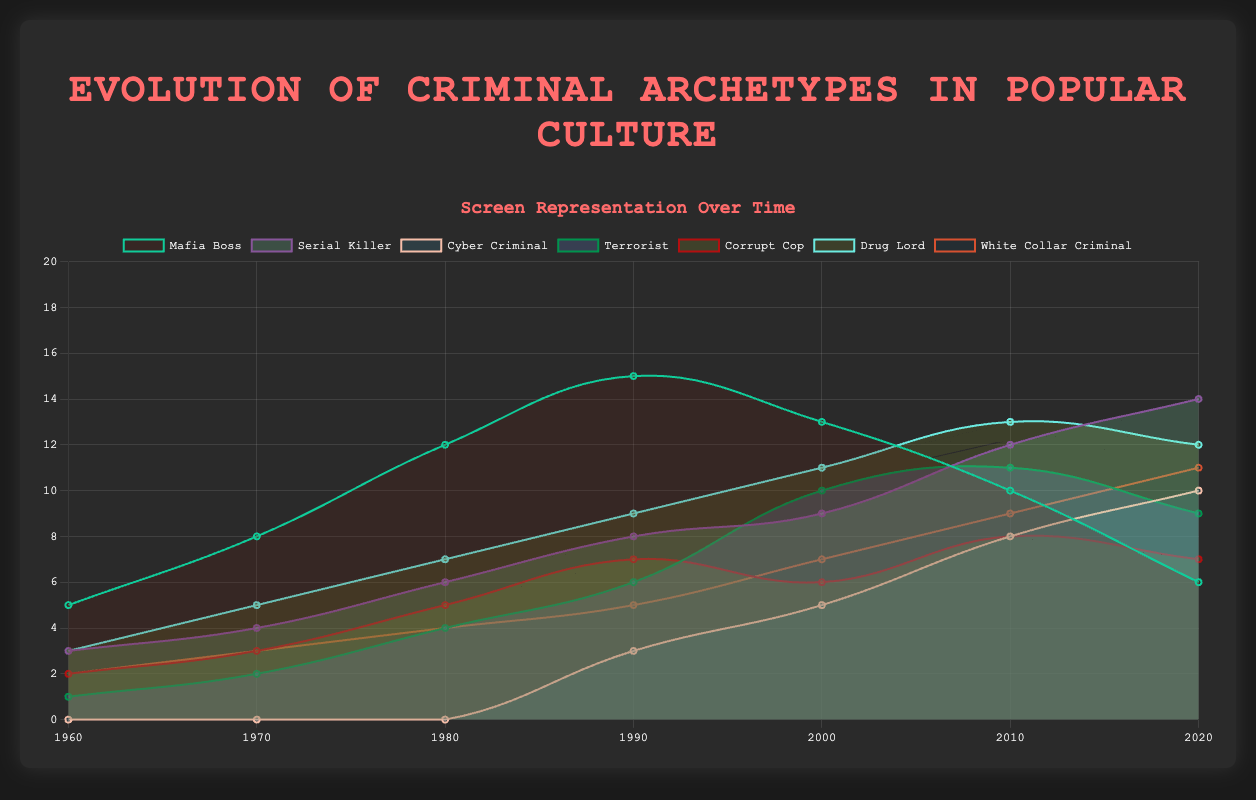What is the title of the chart? The title of the chart is prominently displayed at the top of the figure.
Answer: Evolution of Criminal Archetypes in Popular Culture How many years are represented in the chart? Counting the years provided in the x-axis labels from 1960 to 2020, we see there are 7.
Answer: 7 Which criminal archetype shows the highest screen representation in 2010? Finding the data point in 2010 for each archetype and comparing their values, the highest value is 13 for "Drug Lord".
Answer: Drug Lord By how much did the representation of "Cyber Criminal" increase from 2000 to 2020? "Cyber Criminal" representation in 2000 is 5, and in 2020 it is 10. The increase is calculated as 10 - 5.
Answer: 5 Which archetype had a decline in representation from 2010 to 2020? Observing the trends from 2010 to 2020, "Mafia Boss" (from 10 to 6) and "Terrorist" (from 11 to 9) both show a decline.
Answer: Mafia Boss, Terrorist Which archetype had the lowest representation in 1980? Looking at the values in 1980, "Cyber Criminal" is 0, which is the lowest.
Answer: Cyber Criminal What is the average screen representation of "Serial Killer" throughout the years shown? Summing the values for "Serial Killer" (3, 4, 6, 8, 9, 12, 14) and dividing by 7 (the number of years) gives an average of (3+4+6+8+9+12+14)/7.
Answer: 8 Compare the portrayal trends of "Mafia Boss" and "Serial Killer" over the years. Which had a more consistent increase? Observing both lines, "Serial Killer" shows a steady increase over time, while "Mafia Boss" rises rapidly until 1990 and then decreases.
Answer: Serial Killer Which archetype consistently had a representation higher than 5 from 2000 to 2020? Checking each archetype's values from 2000 to 2020, "Serial Killer," "Drug Lord," and "White Collar Criminal" consistently show values higher than 5.
Answer: Serial Killer, Drug Lord, White Collar Criminal What is the combined representation of "Drug Lord" and "White Collar Criminal" in 2000? Adding the values for "Drug Lord" (11) and "White Collar Criminal" (7) in 2000, the sum is 11 + 7.
Answer: 18 